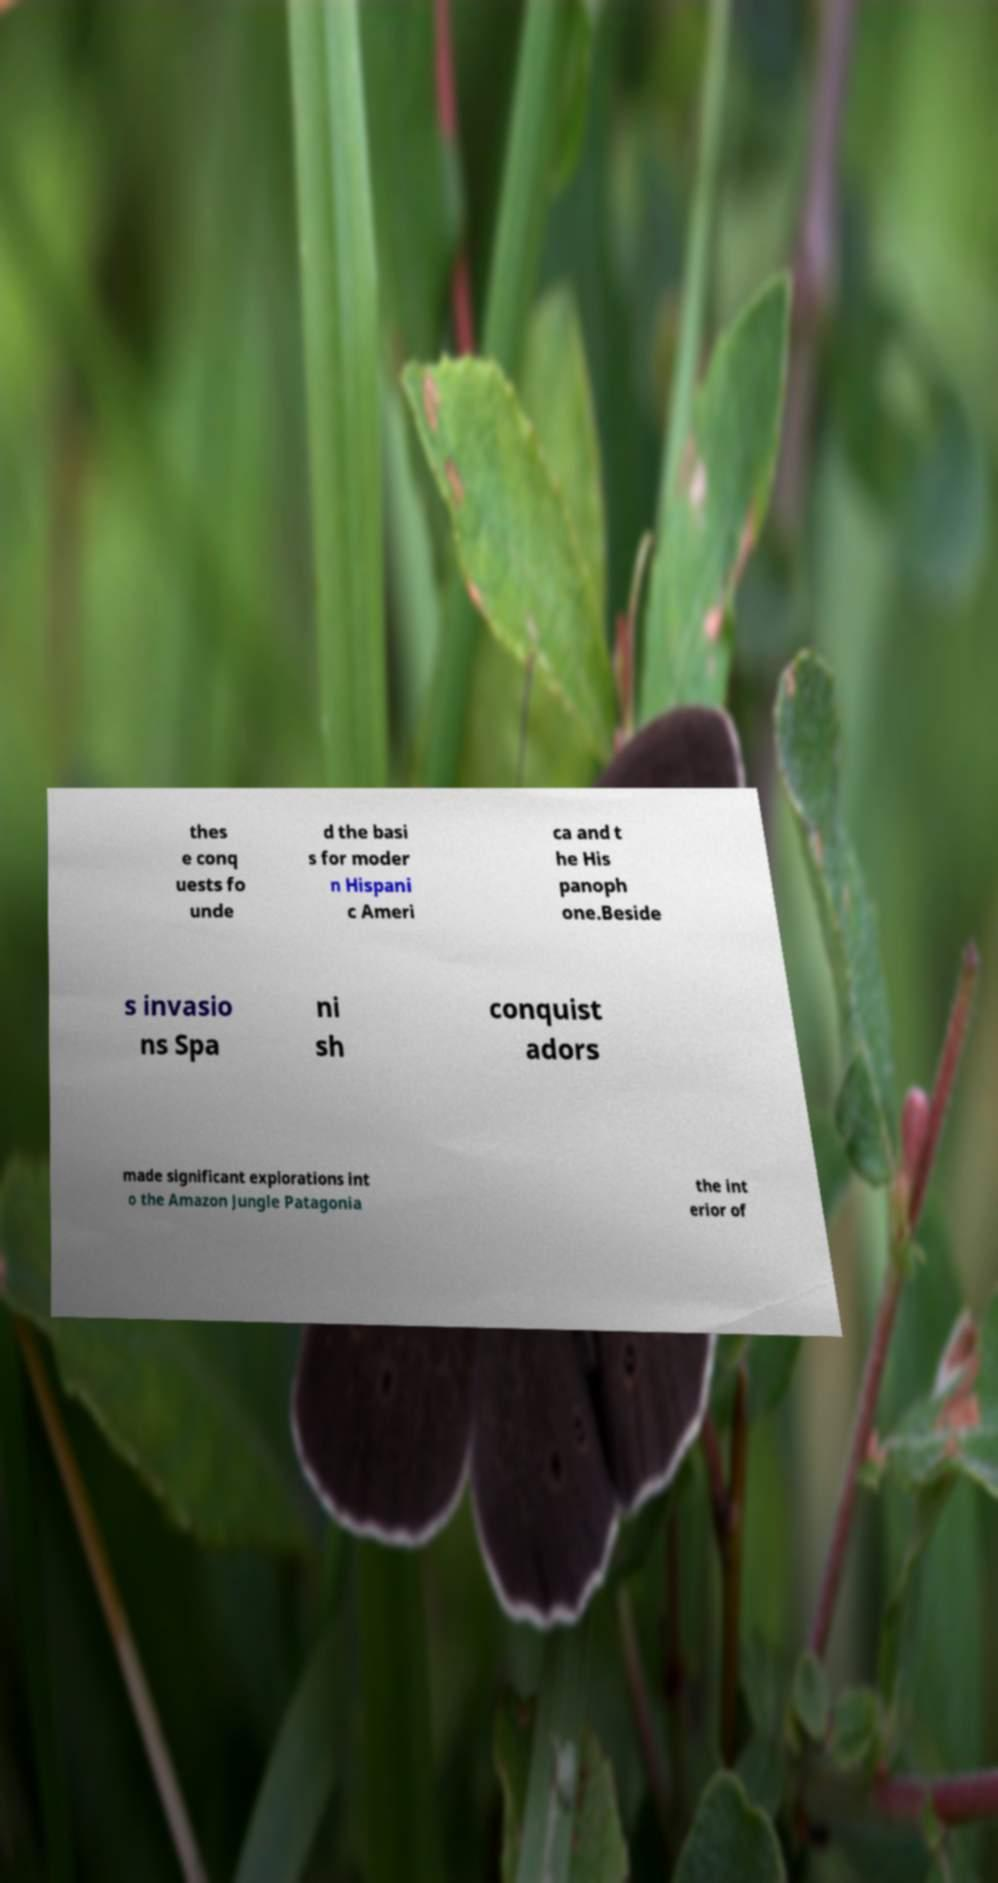Can you accurately transcribe the text from the provided image for me? thes e conq uests fo unde d the basi s for moder n Hispani c Ameri ca and t he His panoph one.Beside s invasio ns Spa ni sh conquist adors made significant explorations int o the Amazon Jungle Patagonia the int erior of 